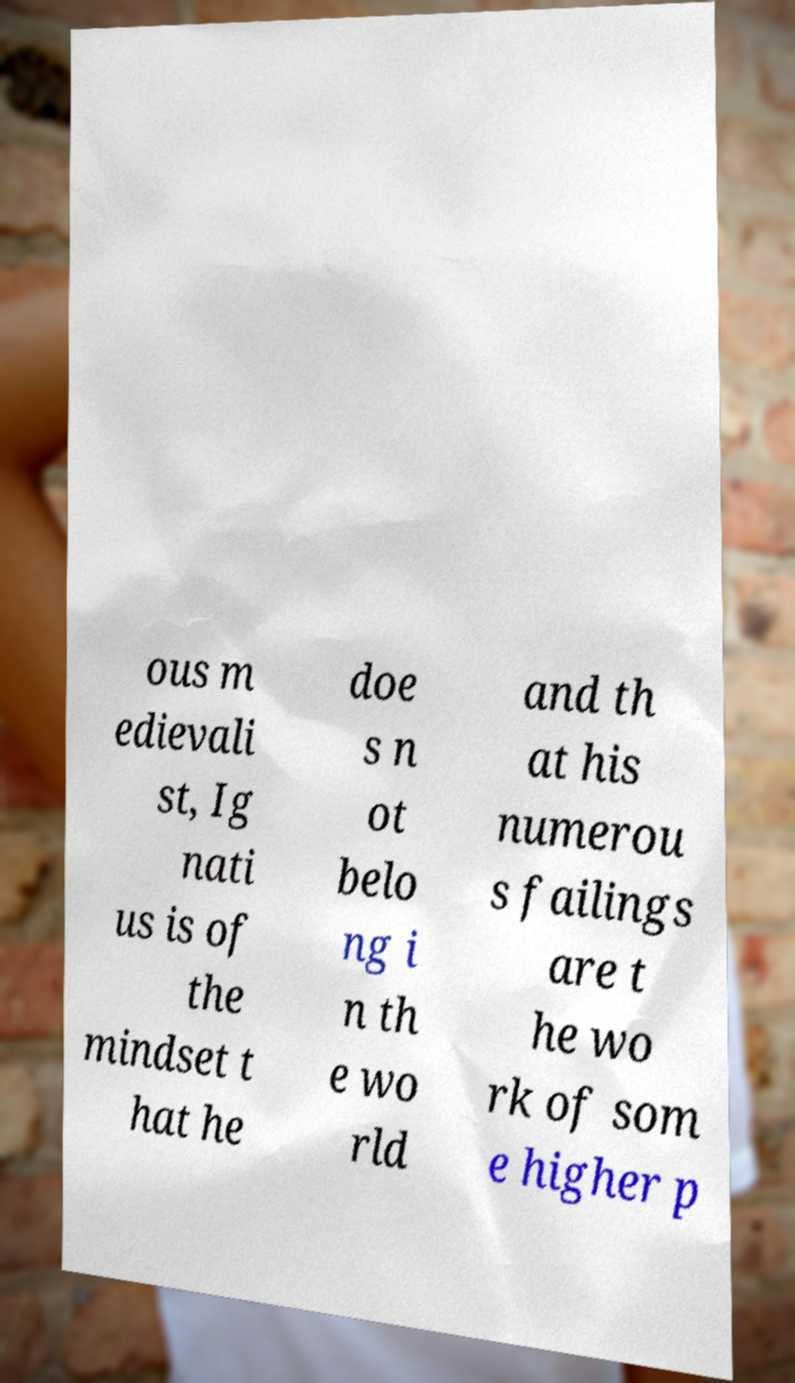I need the written content from this picture converted into text. Can you do that? ous m edievali st, Ig nati us is of the mindset t hat he doe s n ot belo ng i n th e wo rld and th at his numerou s failings are t he wo rk of som e higher p 